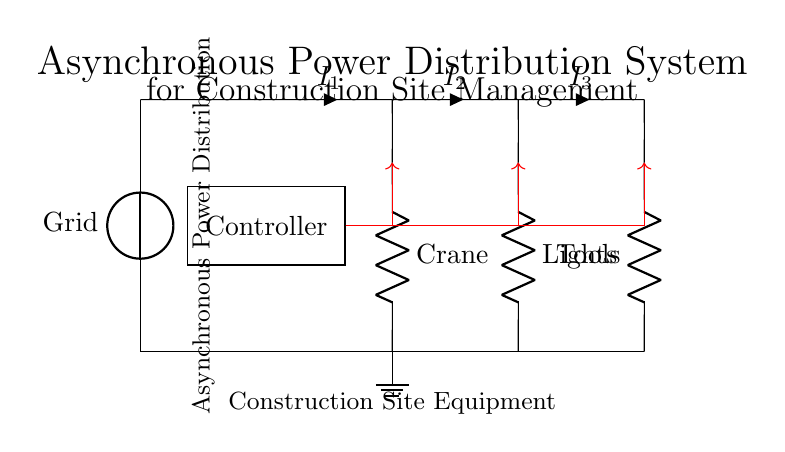What components are connected to the asynchronous controller? The asynchronous controller connects to three components: Crane, Lights, and Tools. These components receive control signals from the controller.
Answer: Crane, Lights, Tools What is the purpose of the controller in this circuit? The controller regulates the operation of various loads by sending signals to the Crane, Lights, and Tools. It manages power distribution according to construction site needs.
Answer: Regulation How many loads are depicted in this circuit? There are three loads shown in the circuit: the Crane, Lights, and Tools, each receiving power from the distribution line.
Answer: Three Which component is represented as a ground in the circuit? The ground in the circuit is represented by a node at the bottom connected to the loads, providing a reference point for voltage. It is illustrated as a ground symbol located near the Crane.
Answer: Ground What type of power source is utilized in this circuit? The power source in this circuit is an electrical grid, indicated by the voltage source symbol labeled "Grid." This provides the necessary electrical energy for the system.
Answer: Grid What does the red arrow signify in the circuit diagram? The red arrows indicate control signals being sent from the controller to the specific loads: Crane, Lights, and Tools, showing their dependence on the controller for power management.
Answer: Control signals How does the current flow through the circuit towards the loads? Current flows through the distribution lines connecting from the Grid to the controller and then branches out to the loads (Crane, Lights, Tools) according to their connected wiring layout.
Answer: Through distribution lines 